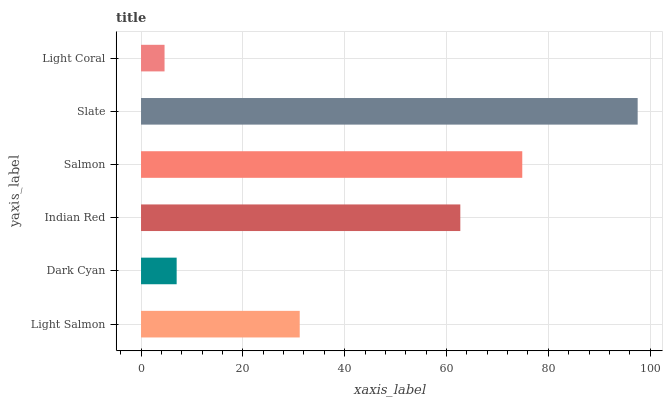Is Light Coral the minimum?
Answer yes or no. Yes. Is Slate the maximum?
Answer yes or no. Yes. Is Dark Cyan the minimum?
Answer yes or no. No. Is Dark Cyan the maximum?
Answer yes or no. No. Is Light Salmon greater than Dark Cyan?
Answer yes or no. Yes. Is Dark Cyan less than Light Salmon?
Answer yes or no. Yes. Is Dark Cyan greater than Light Salmon?
Answer yes or no. No. Is Light Salmon less than Dark Cyan?
Answer yes or no. No. Is Indian Red the high median?
Answer yes or no. Yes. Is Light Salmon the low median?
Answer yes or no. Yes. Is Slate the high median?
Answer yes or no. No. Is Light Coral the low median?
Answer yes or no. No. 